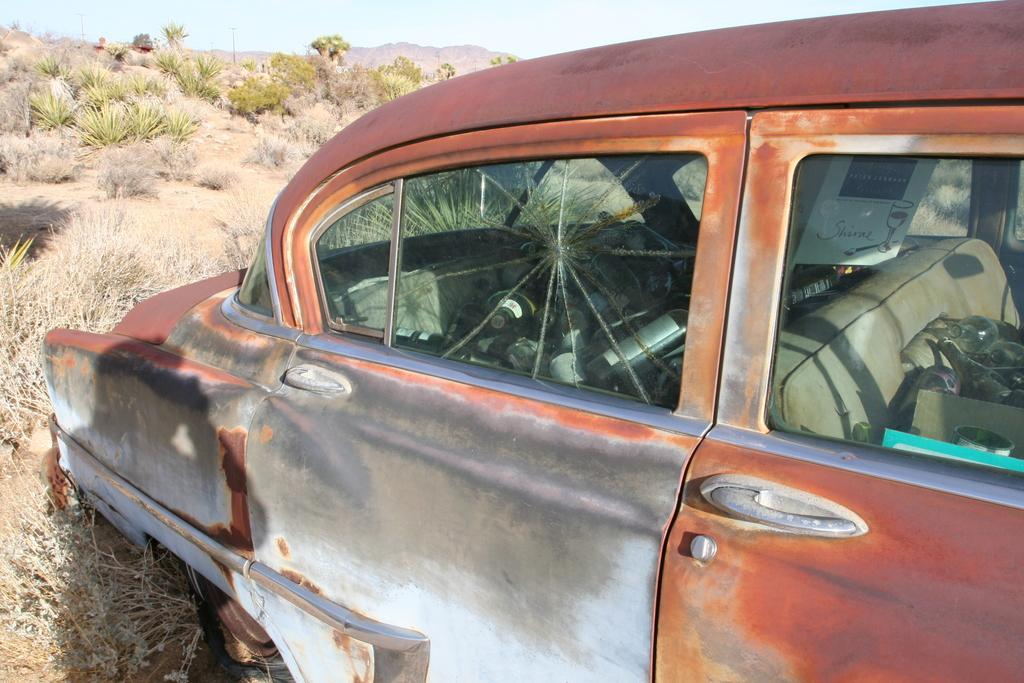What is the main subject of the image? The main subject of the image is a car. What type of natural environment is visible in the image? There is grass, plants, trees, and a hill in the image, which suggests a natural environment. What can be seen in the background of the image? The sky is visible in the background of the image. What type of kitty is sitting on the car's hood in the image? There is no kitty present on the car's hood in the image. What request is being made by the car in the image? Cars do not make requests, as they are inanimate objects. 